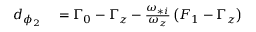<formula> <loc_0><loc_0><loc_500><loc_500>\begin{array} { r l } { d _ { \phi _ { 2 } } } & = \Gamma _ { 0 } - \Gamma _ { z } - \frac { \omega _ { * i } } { \omega _ { z } } \left ( F _ { 1 } - \Gamma _ { z } \right ) } \end{array}</formula> 